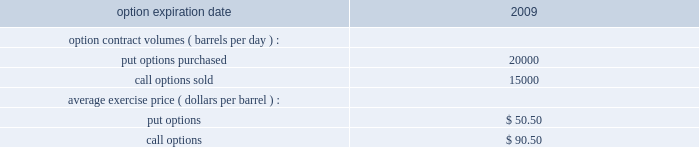Underlying physical transaction occurs .
We have not qualified commodity derivative instruments used in our osm or rm&t segments for hedge accounting .
As a result , we recognize in net income all changes in the fair value of derivative instruments used in those operations .
Open commodity derivative positions as of december 31 , 2008 and sensitivity analysis at december 31 , 2008 , our e&p segment held open derivative contracts to mitigate the price risk on natural gas held in storage or purchased to be marketed with our own natural gas production in amounts that were in line with normal levels of activity .
At december 31 , 2008 , we had no significant open derivative contracts related to our future sales of liquid hydrocarbons and natural gas and therefore remained substantially exposed to market prices of these commodities .
The osm segment holds crude oil options which were purchased by western for a three year period ( january 2007 to december 2009 ) .
The premiums for the purchased put options had been partially offset through the sale of call options for the same three-year period , resulting in a net premium liability .
Payment of the net premium liability is deferred until the settlement of the option contracts .
As of december 31 , 2008 , the following put and call options were outstanding: .
In the first quarter of 2009 , we sold derivative instruments at an average exercise price of $ 50.50 which effectively offset the open put options for the remainder of 2009 .
At december 31 , 2008 , the number of open derivative contracts held by our rm&t segment was lower than in previous periods .
Starting in the second quarter of 2008 , we decreased our use of derivatives to mitigate crude oil price risk between the time that domestic spot crude oil purchases are priced and when they are actually refined into salable petroleum products .
Instead , we are addressing this price risk through other means , including changes in contractual terms and crude oil acquisition practices .
Additionally , in previous periods , certain contracts in our rm&t segment for the purchase or sale of commodities were not qualified or designated as normal purchase or normal sales under generally accepted accounting principles and therefore were accounted for as derivative instruments .
During the second quarter of 2008 , as we decreased our use of derivatives , we began to designate such contracts for the normal purchase and normal sale exclusion. .
Using the above listed average exercise price , what were the value of the put options purchased? 
Computations: (20000 * 50.50)
Answer: 1010000.0. 